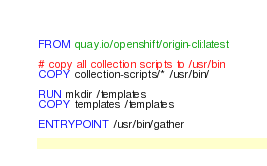Convert code to text. <code><loc_0><loc_0><loc_500><loc_500><_Dockerfile_>FROM quay.io/openshift/origin-cli:latest

# copy all collection scripts to /usr/bin
COPY collection-scripts/* /usr/bin/

RUN mkdir /templates
COPY templates /templates

ENTRYPOINT /usr/bin/gather
</code> 